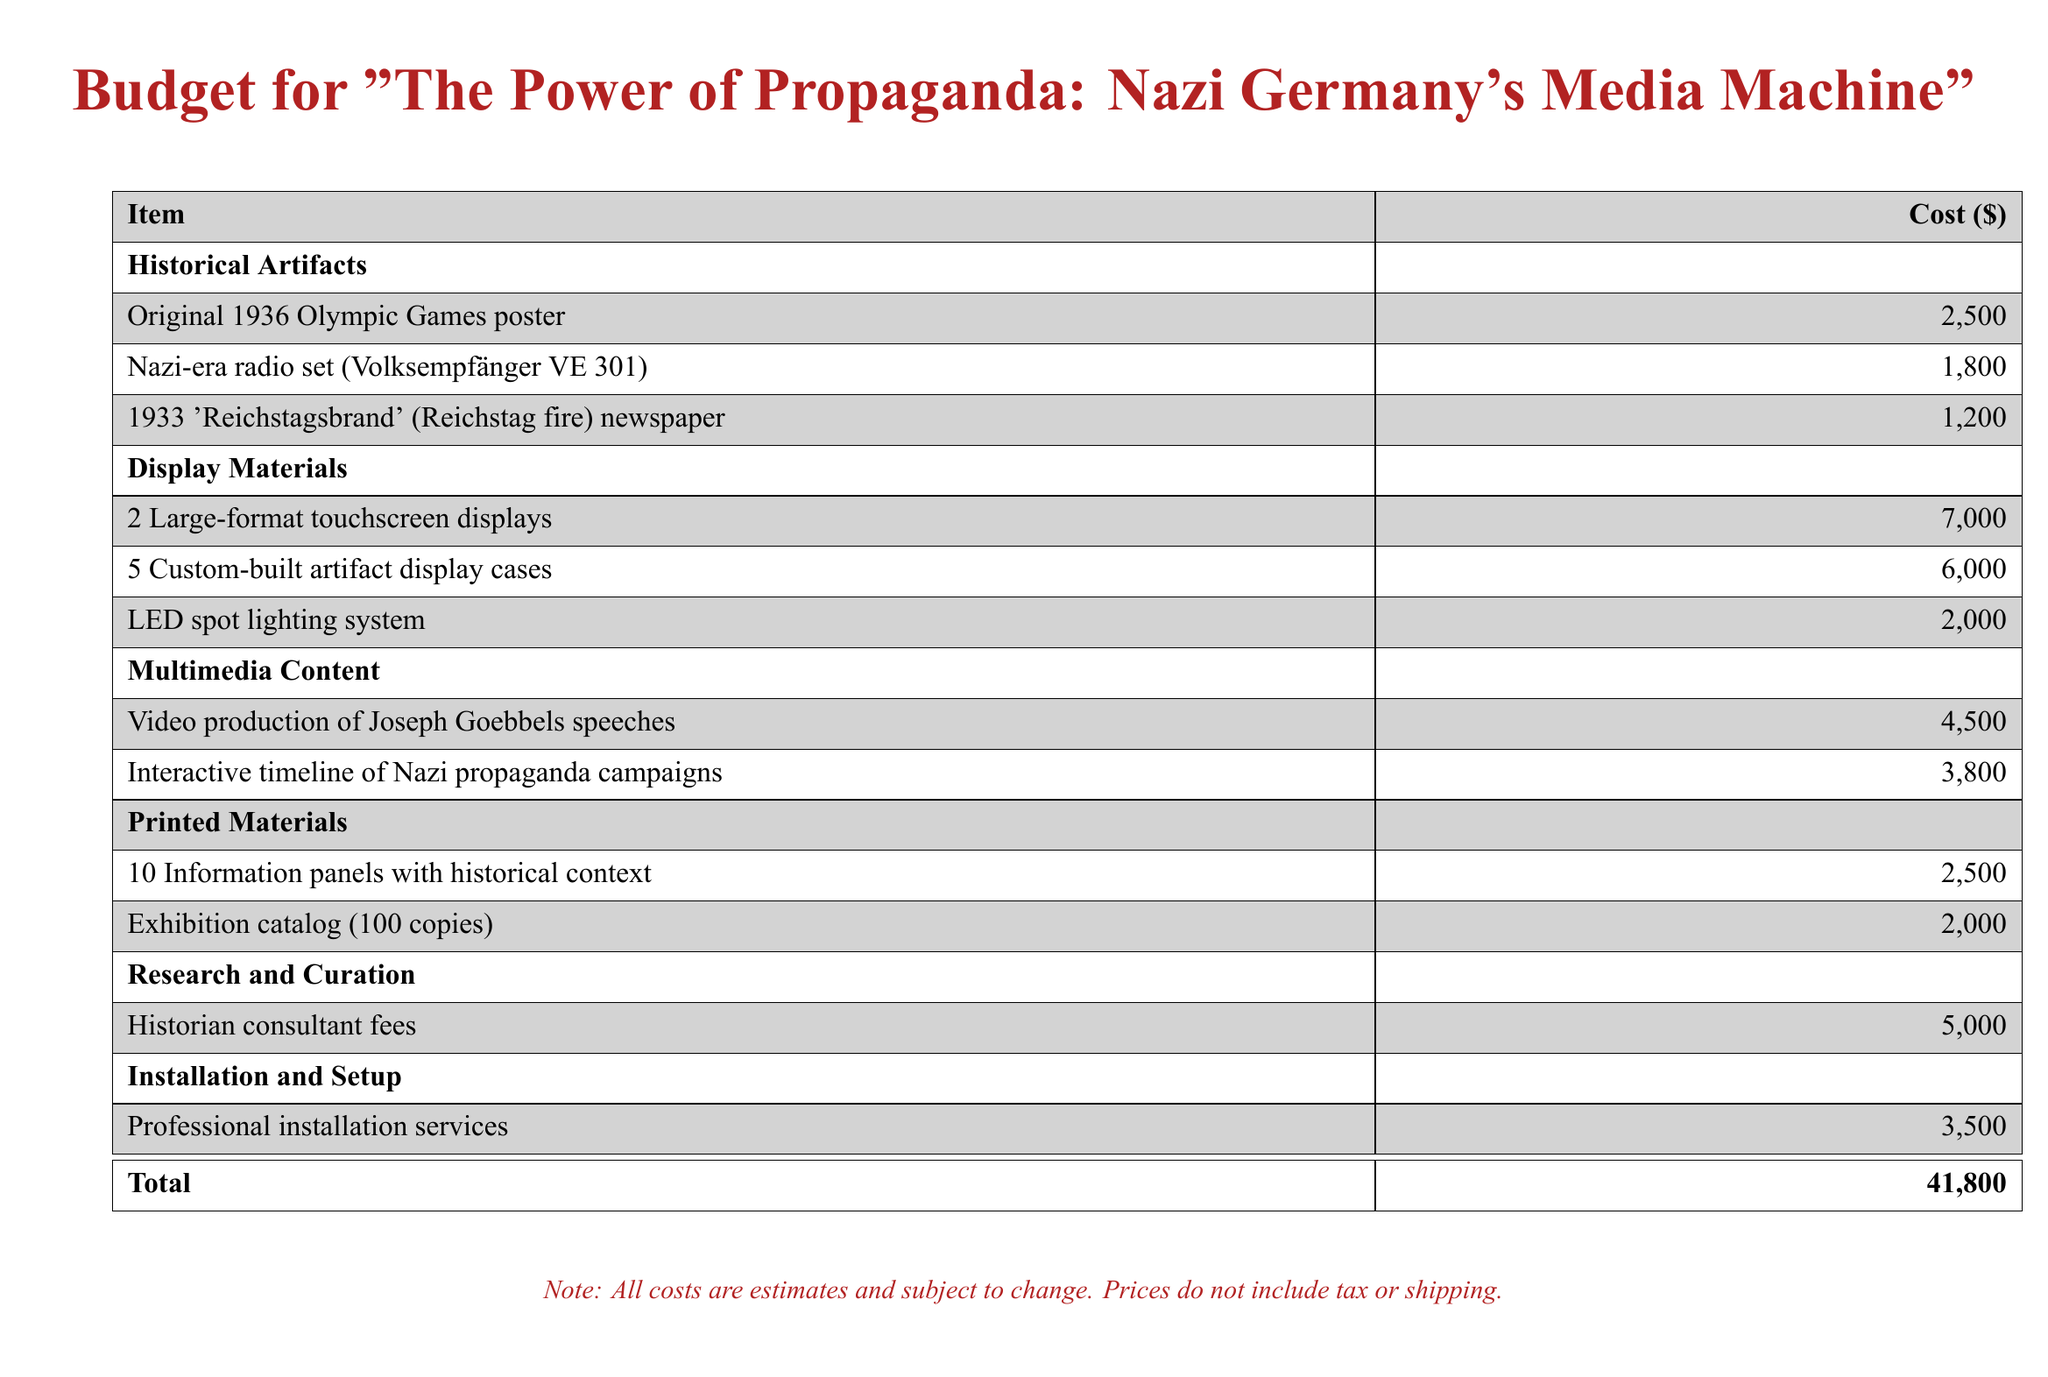What is the total budget? The total budget is presented at the bottom of the document and is the sum of all item costs.
Answer: 41,800 How much does the original 1936 Olympic Games poster cost? The cost for the original 1936 Olympic Games poster is specified in the historical artifacts section.
Answer: 2,500 How many custom-built artifact display cases are included in the budget? The number of custom-built artifact display cases is indicated in the display materials section.
Answer: 5 What is the cost of the video production of Joseph Goebbels speeches? The cost for video production is listed under multimedia content in the document.
Answer: 4,500 What type of professional service is included in the installation and setup? The service type mentioned for installation is specific and included in the installation and setup section.
Answer: Professional installation services What is the cost of the historian consultant fees? The cost for historian consultant fees is found in the research and curation section of the document.
Answer: 5,000 Which item costs 2,000 dollars? The item priced at 2,000 dollars is identified in the printed materials section.
Answer: Exhibition catalog What is the purpose of the large-format touchscreen displays? The purpose of the large-format touchscreen displays can be inferred from the document's multimedia exhibit context.
Answer: Display materials How many copies of the exhibition catalog are budgeted? The document specifies the number of copies budgeted for the exhibition catalog in the printed materials section.
Answer: 100 What does the note at the bottom of the document mention? The note provides important details regarding cost estimates and possible changes.
Answer: Estimates and subject to change 